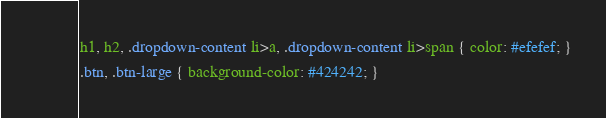Convert code to text. <code><loc_0><loc_0><loc_500><loc_500><_CSS_>h1, h2, .dropdown-content li>a, .dropdown-content li>span { color: #efefef; }
.btn, .btn-large { background-color: #424242; }</code> 